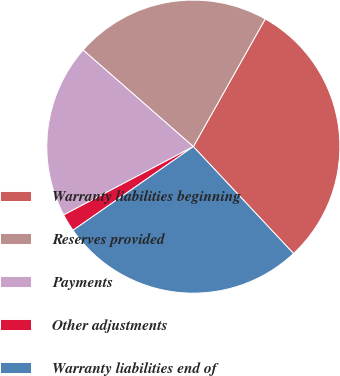<chart> <loc_0><loc_0><loc_500><loc_500><pie_chart><fcel>Warranty liabilities beginning<fcel>Reserves provided<fcel>Payments<fcel>Other adjustments<fcel>Warranty liabilities end of<nl><fcel>29.85%<fcel>21.71%<fcel>19.17%<fcel>1.95%<fcel>27.31%<nl></chart> 